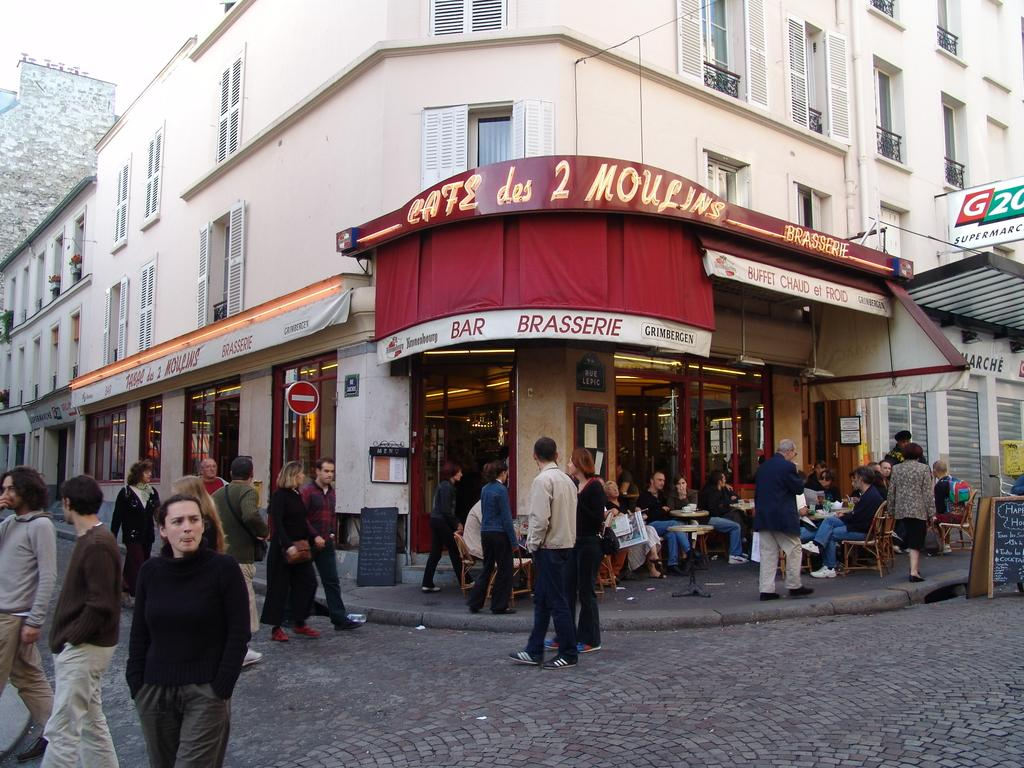What are the people in the image doing? There is a group of people standing and another group sitting on chairs in the image. What objects are present in the image that the people might be using? There are tables in the image that the people might be using. What else can be seen in the image besides the people and tables? There are boards in the image. What can be seen in the background of the image? There are buildings in the background of the image. Can you see any monkeys at the edge of the image? There are no monkeys or edges present in the image; it features a group of people standing and sitting, tables, boards, and buildings in the background. 